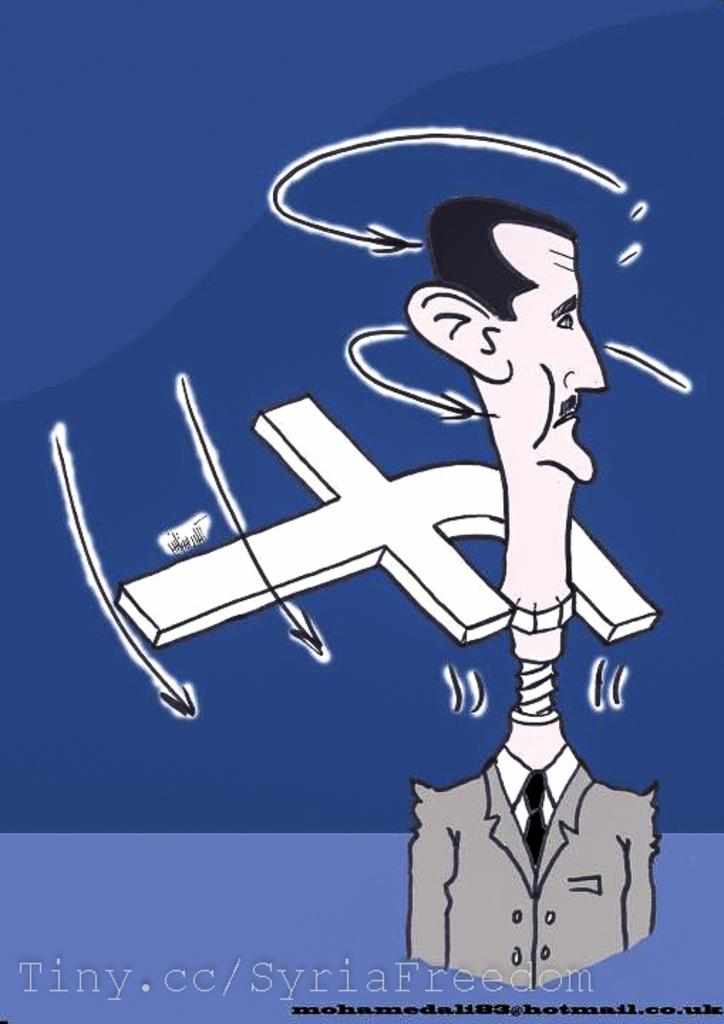<image>
Share a concise interpretation of the image provided. a man with a long neck and the letter F behind him 